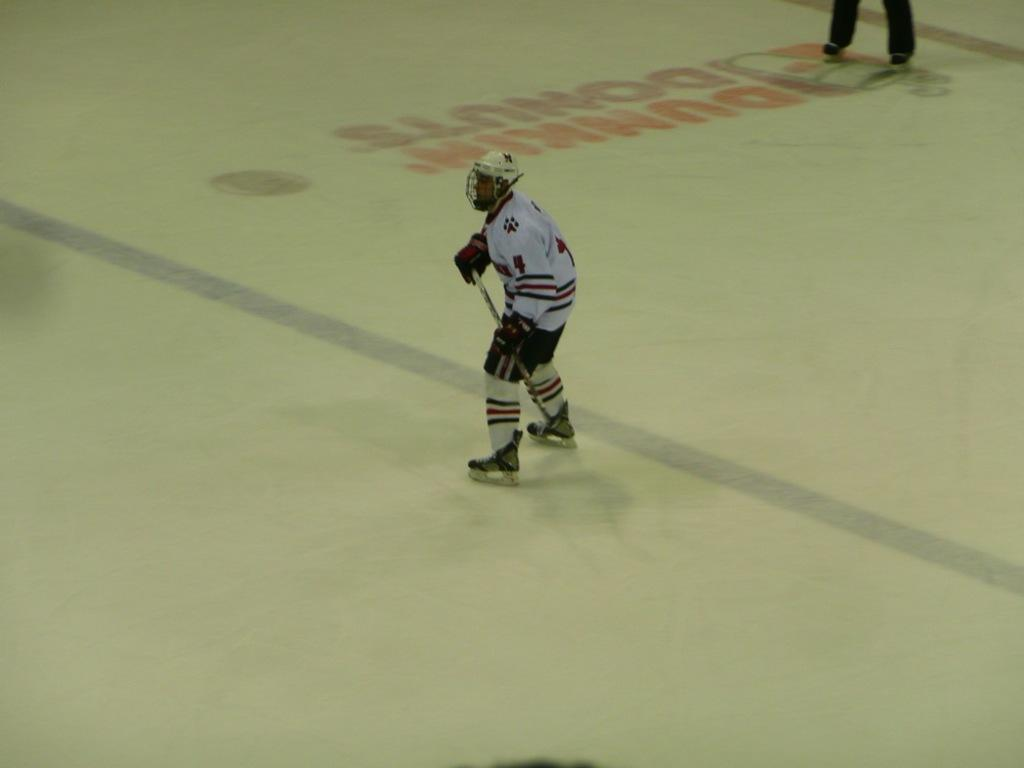<image>
Write a terse but informative summary of the picture. Hockey player on ice with Dunkin Donuts logo on the ice 